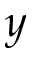Convert formula to latex. <formula><loc_0><loc_0><loc_500><loc_500>y</formula> 